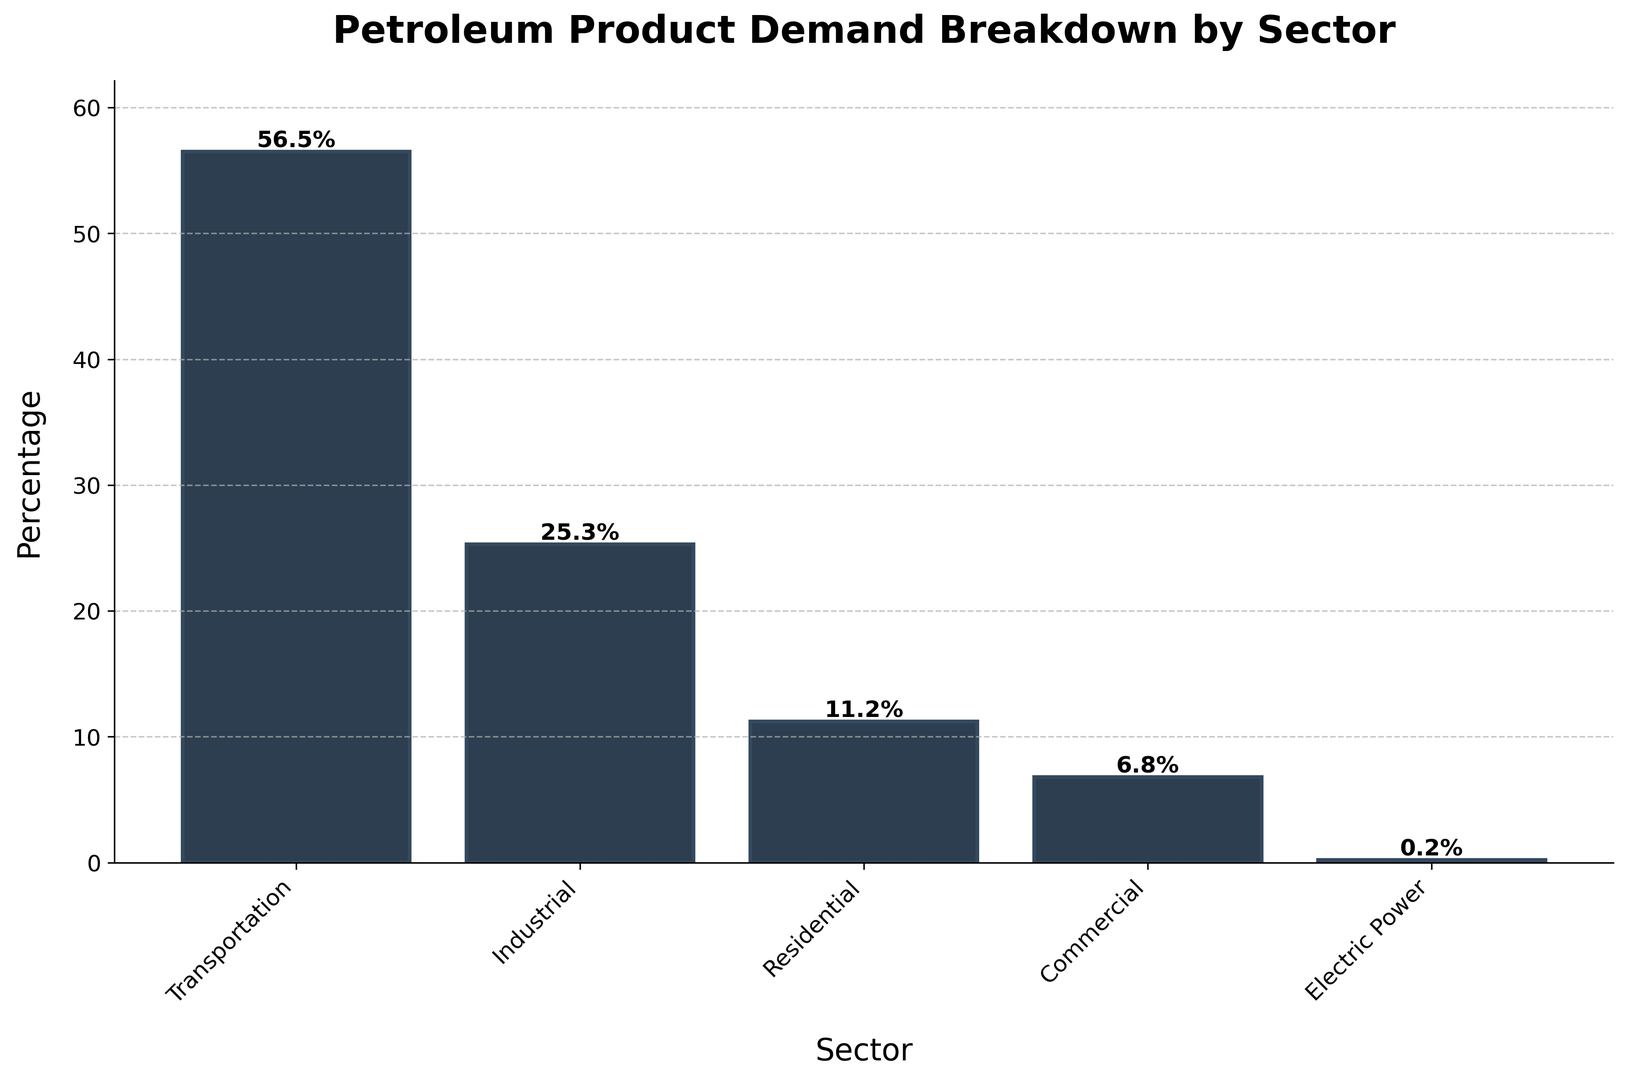What sector has the highest petroleum product demand? By looking at the heights of the bars in the chart, the transportation sector has the tallest bar, indicating that it has the highest petroleum product demand.
Answer: Transportation Which sectors combined account for more than 80% of the petroleum product demand? Adding the percentages of the transportation, industrial, and residential sectors: 56.5% (Transportation) + 25.3% (Industrial) = 81.8%. Since 81.8% > 80%, these sectors combined account for more than 80% of the demand.
Answer: Transportation, Industrial What is the difference in percentage demand between the Transportation and Industrial sectors? Subtract the Industrial demand percentage from the Transportation demand percentage: 56.5% - 25.3% = 31.2%
Answer: 31.2% Which sector has the least demand for petroleum products? The sector with the shortest bar represents the least demand, which is the Electric Power sector with 0.2%.
Answer: Electric Power What percentage of demand does the Commercial sector contribute, and how does it compare to the Residential sector? The Commercial sector contributes 6.8%. Comparing it to the Residential sector, which contributes 11.2%, the Commercial demand is 4.4% less: 11.2% - 6.8% = 4.4%.
Answer: 6.8%, 4.4% less Combine the Residential, Commercial, and Electric Power sectors. Do they collectively demand more than the Industrial sector? Adding the Residential, Commercial, and Electric Power percentages: 11.2% (Residential) + 6.8% (Commercial) + 0.2% (Electric Power) = 18.2%. Since 18.2% < 25.3%, they collectively demand less than the Industrial sector.
Answer: No How much higher in percentage is the demand for petroleum products in the Transportation sector compared to the Residential sector? Subtract the Residential sector's demand from the Transportation sector's demand: 56.5% - 11.2% = 45.3%.
Answer: 45.3% What visual characteristics indicate the sector with the highest demand? The bar representing the transportation sector is the tallest and has the percentage label of 56.5% on top, indicating it has the highest demand visually.
Answer: Tallest bar, 56.5% What is the average demand for petroleum products across all sectors? To find the average, sum up all the values and divide by the number of sectors: (56.5% + 25.3% + 11.2% + 6.8% + 0.2%) / 5 = 100% / 5 = 20%.
Answer: 20% 